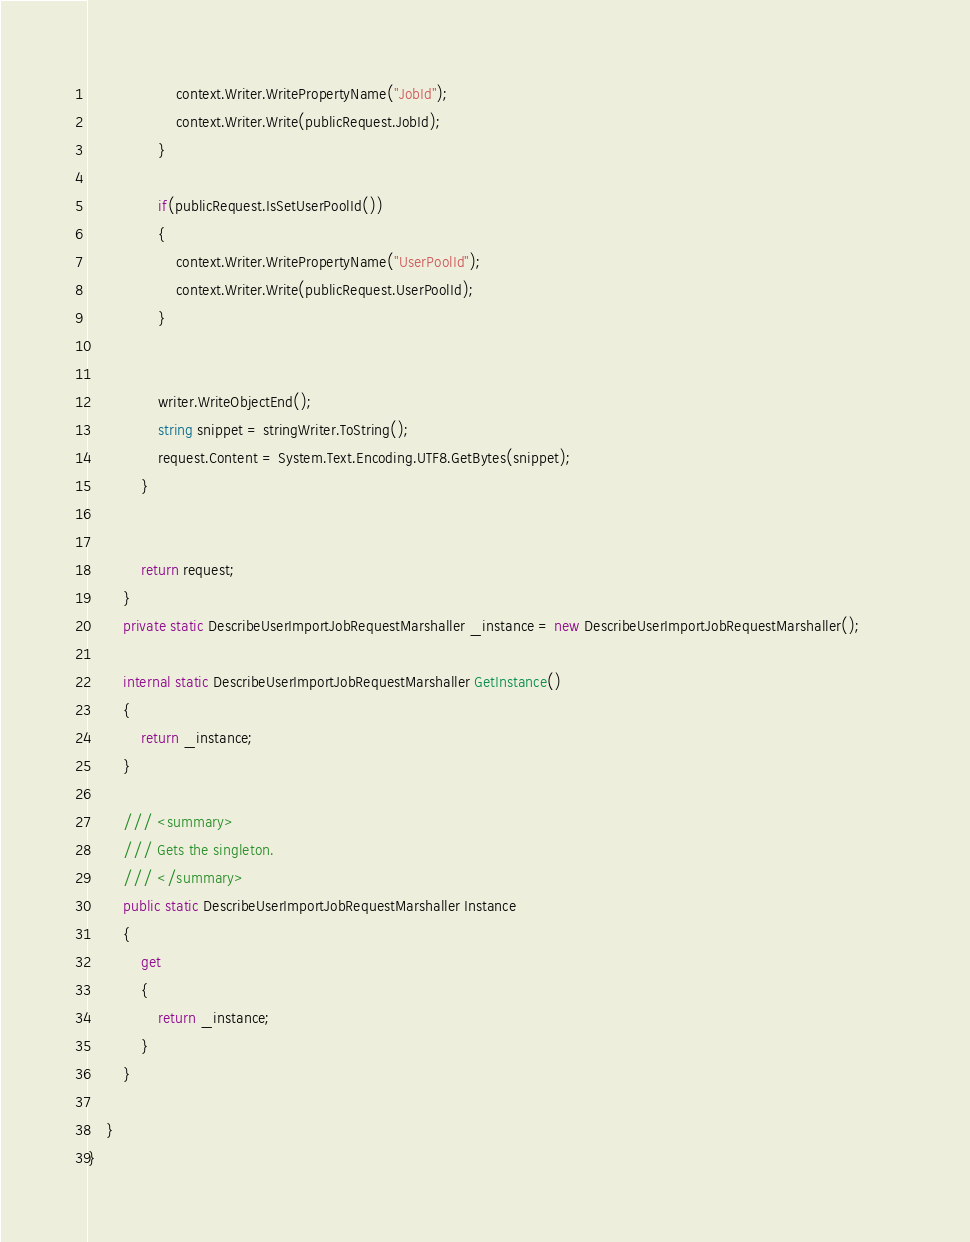<code> <loc_0><loc_0><loc_500><loc_500><_C#_>                    context.Writer.WritePropertyName("JobId");
                    context.Writer.Write(publicRequest.JobId);
                }

                if(publicRequest.IsSetUserPoolId())
                {
                    context.Writer.WritePropertyName("UserPoolId");
                    context.Writer.Write(publicRequest.UserPoolId);
                }

        
                writer.WriteObjectEnd();
                string snippet = stringWriter.ToString();
                request.Content = System.Text.Encoding.UTF8.GetBytes(snippet);
            }


            return request;
        }
        private static DescribeUserImportJobRequestMarshaller _instance = new DescribeUserImportJobRequestMarshaller();        

        internal static DescribeUserImportJobRequestMarshaller GetInstance()
        {
            return _instance;
        }

        /// <summary>
        /// Gets the singleton.
        /// </summary>  
        public static DescribeUserImportJobRequestMarshaller Instance
        {
            get
            {
                return _instance;
            }
        }

    }
}</code> 